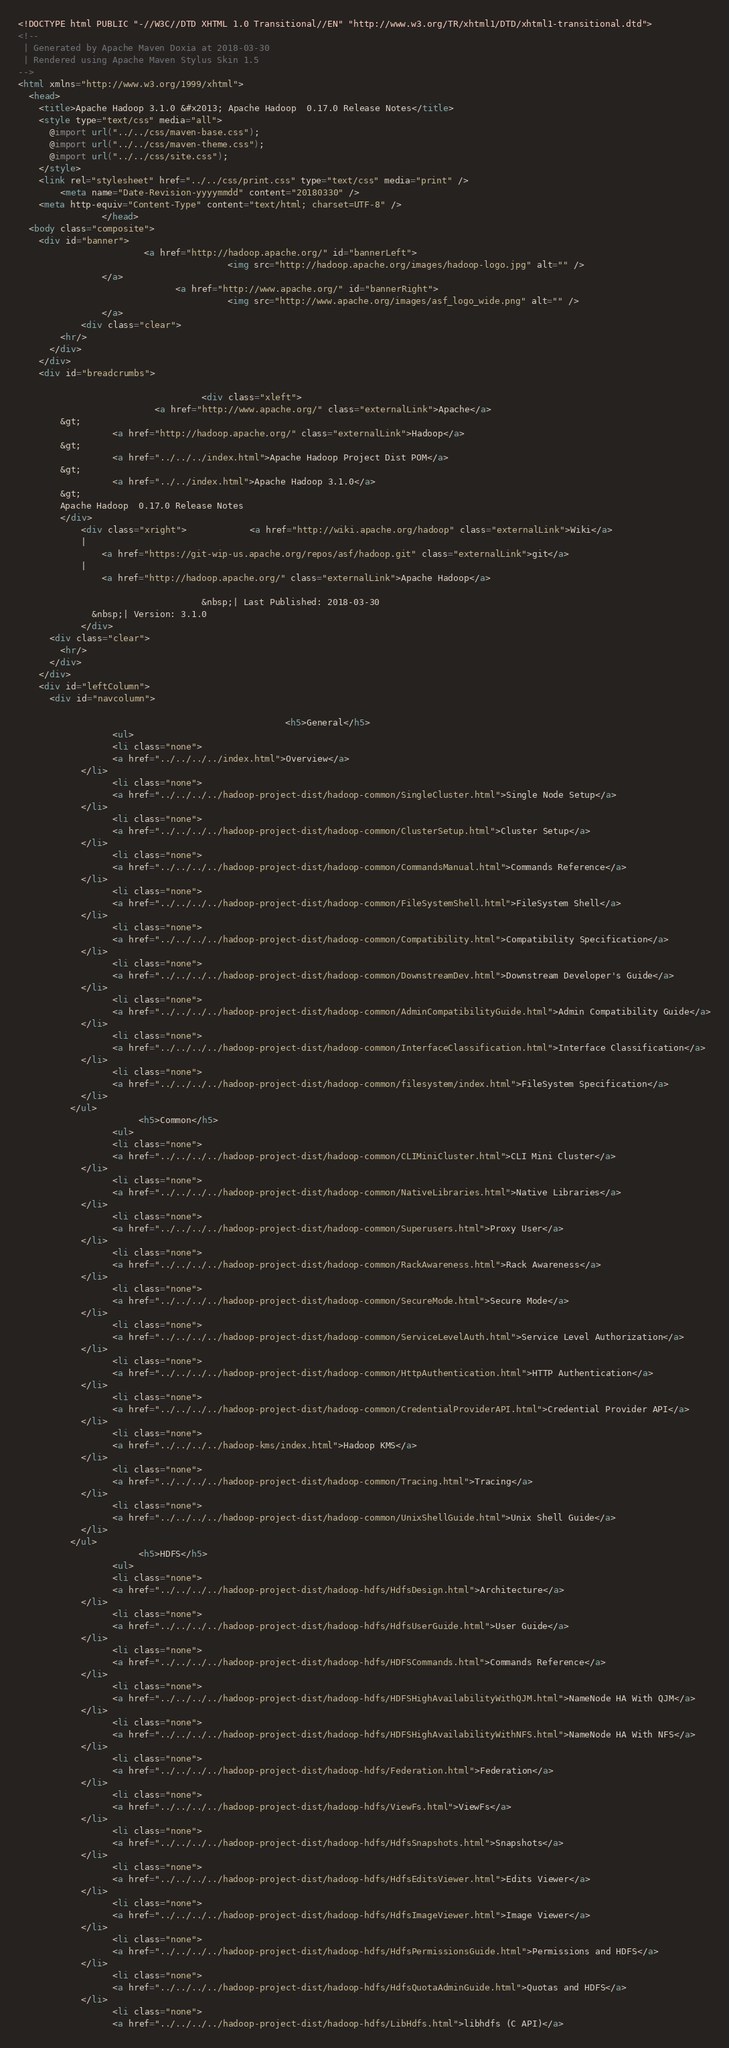<code> <loc_0><loc_0><loc_500><loc_500><_HTML_><!DOCTYPE html PUBLIC "-//W3C//DTD XHTML 1.0 Transitional//EN" "http://www.w3.org/TR/xhtml1/DTD/xhtml1-transitional.dtd">
<!--
 | Generated by Apache Maven Doxia at 2018-03-30
 | Rendered using Apache Maven Stylus Skin 1.5
-->
<html xmlns="http://www.w3.org/1999/xhtml">
  <head>
    <title>Apache Hadoop 3.1.0 &#x2013; Apache Hadoop  0.17.0 Release Notes</title>
    <style type="text/css" media="all">
      @import url("../../css/maven-base.css");
      @import url("../../css/maven-theme.css");
      @import url("../../css/site.css");
    </style>
    <link rel="stylesheet" href="../../css/print.css" type="text/css" media="print" />
        <meta name="Date-Revision-yyyymmdd" content="20180330" />
    <meta http-equiv="Content-Type" content="text/html; charset=UTF-8" />
                </head>
  <body class="composite">
    <div id="banner">
                        <a href="http://hadoop.apache.org/" id="bannerLeft">
                                        <img src="http://hadoop.apache.org/images/hadoop-logo.jpg" alt="" />
                </a>
                              <a href="http://www.apache.org/" id="bannerRight">
                                        <img src="http://www.apache.org/images/asf_logo_wide.png" alt="" />
                </a>
            <div class="clear">
        <hr/>
      </div>
    </div>
    <div id="breadcrumbs">
            
                                   <div class="xleft">
                          <a href="http://www.apache.org/" class="externalLink">Apache</a>
        &gt;
                  <a href="http://hadoop.apache.org/" class="externalLink">Hadoop</a>
        &gt;
                  <a href="../../../index.html">Apache Hadoop Project Dist POM</a>
        &gt;
                  <a href="../../index.html">Apache Hadoop 3.1.0</a>
        &gt;
        Apache Hadoop  0.17.0 Release Notes
        </div>
            <div class="xright">            <a href="http://wiki.apache.org/hadoop" class="externalLink">Wiki</a>
            |
                <a href="https://git-wip-us.apache.org/repos/asf/hadoop.git" class="externalLink">git</a>
            |
                <a href="http://hadoop.apache.org/" class="externalLink">Apache Hadoop</a>
              
                                   &nbsp;| Last Published: 2018-03-30
              &nbsp;| Version: 3.1.0
            </div>
      <div class="clear">
        <hr/>
      </div>
    </div>
    <div id="leftColumn">
      <div id="navcolumn">
             
                                                   <h5>General</h5>
                  <ul>
                  <li class="none">
                  <a href="../../../../index.html">Overview</a>
            </li>
                  <li class="none">
                  <a href="../../../../hadoop-project-dist/hadoop-common/SingleCluster.html">Single Node Setup</a>
            </li>
                  <li class="none">
                  <a href="../../../../hadoop-project-dist/hadoop-common/ClusterSetup.html">Cluster Setup</a>
            </li>
                  <li class="none">
                  <a href="../../../../hadoop-project-dist/hadoop-common/CommandsManual.html">Commands Reference</a>
            </li>
                  <li class="none">
                  <a href="../../../../hadoop-project-dist/hadoop-common/FileSystemShell.html">FileSystem Shell</a>
            </li>
                  <li class="none">
                  <a href="../../../../hadoop-project-dist/hadoop-common/Compatibility.html">Compatibility Specification</a>
            </li>
                  <li class="none">
                  <a href="../../../../hadoop-project-dist/hadoop-common/DownstreamDev.html">Downstream Developer's Guide</a>
            </li>
                  <li class="none">
                  <a href="../../../../hadoop-project-dist/hadoop-common/AdminCompatibilityGuide.html">Admin Compatibility Guide</a>
            </li>
                  <li class="none">
                  <a href="../../../../hadoop-project-dist/hadoop-common/InterfaceClassification.html">Interface Classification</a>
            </li>
                  <li class="none">
                  <a href="../../../../hadoop-project-dist/hadoop-common/filesystem/index.html">FileSystem Specification</a>
            </li>
          </ul>
                       <h5>Common</h5>
                  <ul>
                  <li class="none">
                  <a href="../../../../hadoop-project-dist/hadoop-common/CLIMiniCluster.html">CLI Mini Cluster</a>
            </li>
                  <li class="none">
                  <a href="../../../../hadoop-project-dist/hadoop-common/NativeLibraries.html">Native Libraries</a>
            </li>
                  <li class="none">
                  <a href="../../../../hadoop-project-dist/hadoop-common/Superusers.html">Proxy User</a>
            </li>
                  <li class="none">
                  <a href="../../../../hadoop-project-dist/hadoop-common/RackAwareness.html">Rack Awareness</a>
            </li>
                  <li class="none">
                  <a href="../../../../hadoop-project-dist/hadoop-common/SecureMode.html">Secure Mode</a>
            </li>
                  <li class="none">
                  <a href="../../../../hadoop-project-dist/hadoop-common/ServiceLevelAuth.html">Service Level Authorization</a>
            </li>
                  <li class="none">
                  <a href="../../../../hadoop-project-dist/hadoop-common/HttpAuthentication.html">HTTP Authentication</a>
            </li>
                  <li class="none">
                  <a href="../../../../hadoop-project-dist/hadoop-common/CredentialProviderAPI.html">Credential Provider API</a>
            </li>
                  <li class="none">
                  <a href="../../../../hadoop-kms/index.html">Hadoop KMS</a>
            </li>
                  <li class="none">
                  <a href="../../../../hadoop-project-dist/hadoop-common/Tracing.html">Tracing</a>
            </li>
                  <li class="none">
                  <a href="../../../../hadoop-project-dist/hadoop-common/UnixShellGuide.html">Unix Shell Guide</a>
            </li>
          </ul>
                       <h5>HDFS</h5>
                  <ul>
                  <li class="none">
                  <a href="../../../../hadoop-project-dist/hadoop-hdfs/HdfsDesign.html">Architecture</a>
            </li>
                  <li class="none">
                  <a href="../../../../hadoop-project-dist/hadoop-hdfs/HdfsUserGuide.html">User Guide</a>
            </li>
                  <li class="none">
                  <a href="../../../../hadoop-project-dist/hadoop-hdfs/HDFSCommands.html">Commands Reference</a>
            </li>
                  <li class="none">
                  <a href="../../../../hadoop-project-dist/hadoop-hdfs/HDFSHighAvailabilityWithQJM.html">NameNode HA With QJM</a>
            </li>
                  <li class="none">
                  <a href="../../../../hadoop-project-dist/hadoop-hdfs/HDFSHighAvailabilityWithNFS.html">NameNode HA With NFS</a>
            </li>
                  <li class="none">
                  <a href="../../../../hadoop-project-dist/hadoop-hdfs/Federation.html">Federation</a>
            </li>
                  <li class="none">
                  <a href="../../../../hadoop-project-dist/hadoop-hdfs/ViewFs.html">ViewFs</a>
            </li>
                  <li class="none">
                  <a href="../../../../hadoop-project-dist/hadoop-hdfs/HdfsSnapshots.html">Snapshots</a>
            </li>
                  <li class="none">
                  <a href="../../../../hadoop-project-dist/hadoop-hdfs/HdfsEditsViewer.html">Edits Viewer</a>
            </li>
                  <li class="none">
                  <a href="../../../../hadoop-project-dist/hadoop-hdfs/HdfsImageViewer.html">Image Viewer</a>
            </li>
                  <li class="none">
                  <a href="../../../../hadoop-project-dist/hadoop-hdfs/HdfsPermissionsGuide.html">Permissions and HDFS</a>
            </li>
                  <li class="none">
                  <a href="../../../../hadoop-project-dist/hadoop-hdfs/HdfsQuotaAdminGuide.html">Quotas and HDFS</a>
            </li>
                  <li class="none">
                  <a href="../../../../hadoop-project-dist/hadoop-hdfs/LibHdfs.html">libhdfs (C API)</a></code> 